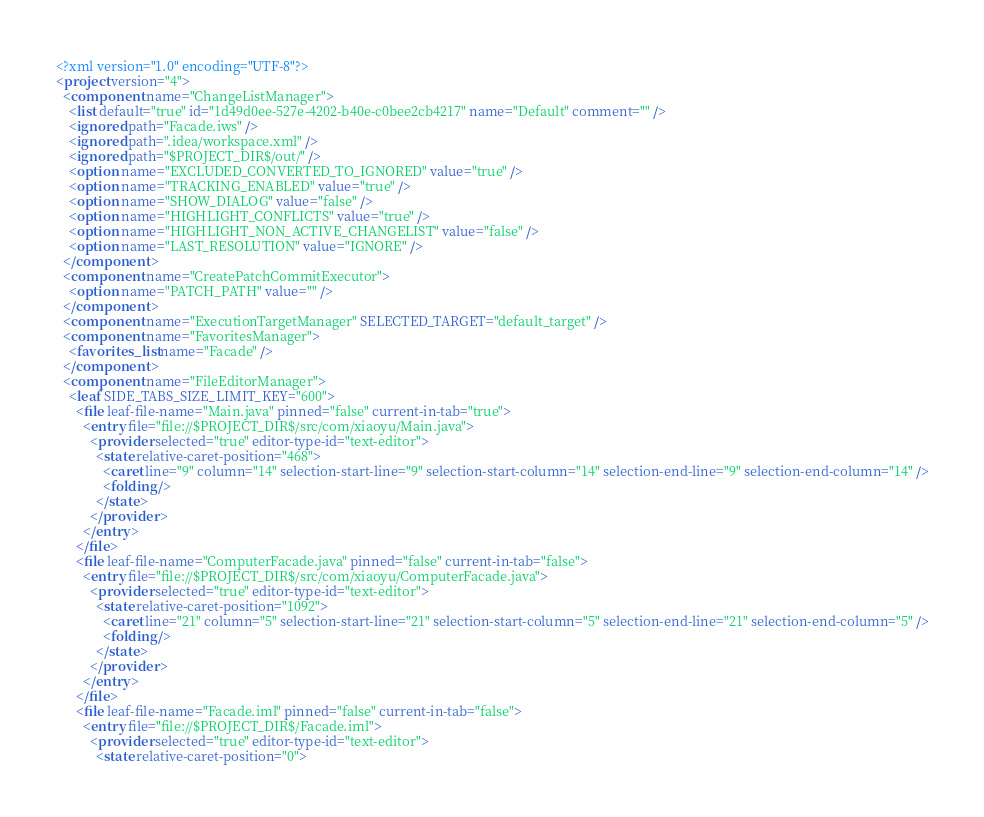<code> <loc_0><loc_0><loc_500><loc_500><_XML_><?xml version="1.0" encoding="UTF-8"?>
<project version="4">
  <component name="ChangeListManager">
    <list default="true" id="1d49d0ee-527e-4202-b40e-c0bee2cb4217" name="Default" comment="" />
    <ignored path="Facade.iws" />
    <ignored path=".idea/workspace.xml" />
    <ignored path="$PROJECT_DIR$/out/" />
    <option name="EXCLUDED_CONVERTED_TO_IGNORED" value="true" />
    <option name="TRACKING_ENABLED" value="true" />
    <option name="SHOW_DIALOG" value="false" />
    <option name="HIGHLIGHT_CONFLICTS" value="true" />
    <option name="HIGHLIGHT_NON_ACTIVE_CHANGELIST" value="false" />
    <option name="LAST_RESOLUTION" value="IGNORE" />
  </component>
  <component name="CreatePatchCommitExecutor">
    <option name="PATCH_PATH" value="" />
  </component>
  <component name="ExecutionTargetManager" SELECTED_TARGET="default_target" />
  <component name="FavoritesManager">
    <favorites_list name="Facade" />
  </component>
  <component name="FileEditorManager">
    <leaf SIDE_TABS_SIZE_LIMIT_KEY="600">
      <file leaf-file-name="Main.java" pinned="false" current-in-tab="true">
        <entry file="file://$PROJECT_DIR$/src/com/xiaoyu/Main.java">
          <provider selected="true" editor-type-id="text-editor">
            <state relative-caret-position="468">
              <caret line="9" column="14" selection-start-line="9" selection-start-column="14" selection-end-line="9" selection-end-column="14" />
              <folding />
            </state>
          </provider>
        </entry>
      </file>
      <file leaf-file-name="ComputerFacade.java" pinned="false" current-in-tab="false">
        <entry file="file://$PROJECT_DIR$/src/com/xiaoyu/ComputerFacade.java">
          <provider selected="true" editor-type-id="text-editor">
            <state relative-caret-position="1092">
              <caret line="21" column="5" selection-start-line="21" selection-start-column="5" selection-end-line="21" selection-end-column="5" />
              <folding />
            </state>
          </provider>
        </entry>
      </file>
      <file leaf-file-name="Facade.iml" pinned="false" current-in-tab="false">
        <entry file="file://$PROJECT_DIR$/Facade.iml">
          <provider selected="true" editor-type-id="text-editor">
            <state relative-caret-position="0"></code> 